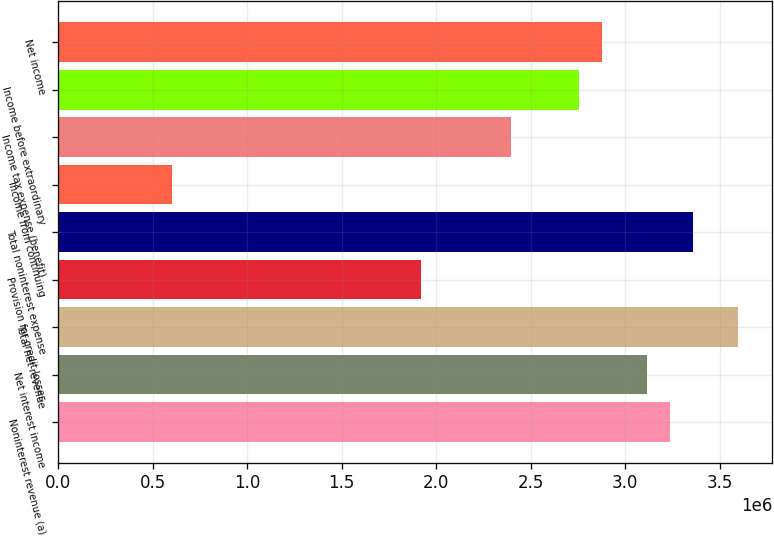<chart> <loc_0><loc_0><loc_500><loc_500><bar_chart><fcel>Noninterest revenue (a)<fcel>Net interest income<fcel>Total net revenue<fcel>Provision for credit losses<fcel>Total noninterest expense<fcel>Income from continuing<fcel>Income tax expense (benefit)<fcel>Income before extraordinary<fcel>Net income<nl><fcel>3.23714e+06<fcel>3.11725e+06<fcel>3.59683e+06<fcel>1.91831e+06<fcel>3.35704e+06<fcel>599471<fcel>2.39788e+06<fcel>2.75757e+06<fcel>2.87746e+06<nl></chart> 